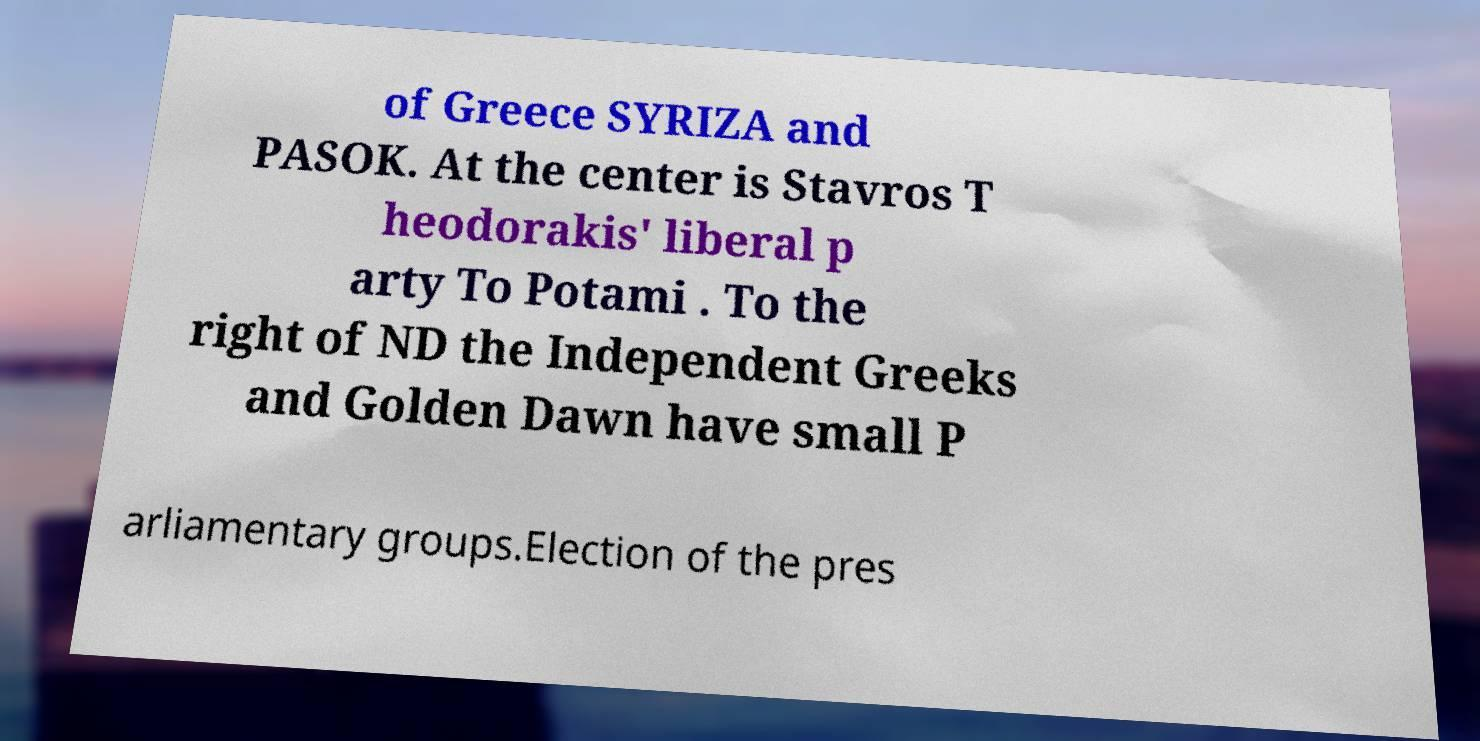Can you accurately transcribe the text from the provided image for me? of Greece SYRIZA and PASOK. At the center is Stavros T heodorakis' liberal p arty To Potami . To the right of ND the Independent Greeks and Golden Dawn have small P arliamentary groups.Election of the pres 